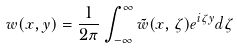<formula> <loc_0><loc_0><loc_500><loc_500>w ( x , y ) = \frac { 1 } { 2 \pi } \int _ { - \infty } ^ { \infty } \tilde { w } ( x , \zeta ) e ^ { i \zeta y } d \zeta</formula> 